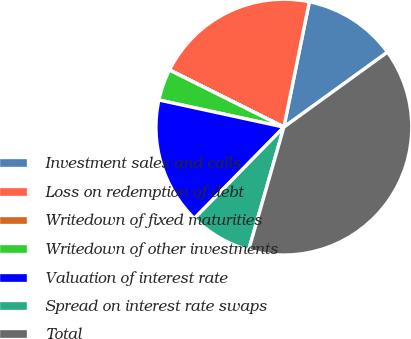Convert chart. <chart><loc_0><loc_0><loc_500><loc_500><pie_chart><fcel>Investment sales and calls<fcel>Loss on redemption of debt<fcel>Writedown of fixed maturities<fcel>Writedown of other investments<fcel>Valuation of interest rate<fcel>Spread on interest rate swaps<fcel>Total<nl><fcel>11.84%<fcel>20.81%<fcel>0.02%<fcel>3.96%<fcel>16.06%<fcel>7.9%<fcel>39.41%<nl></chart> 